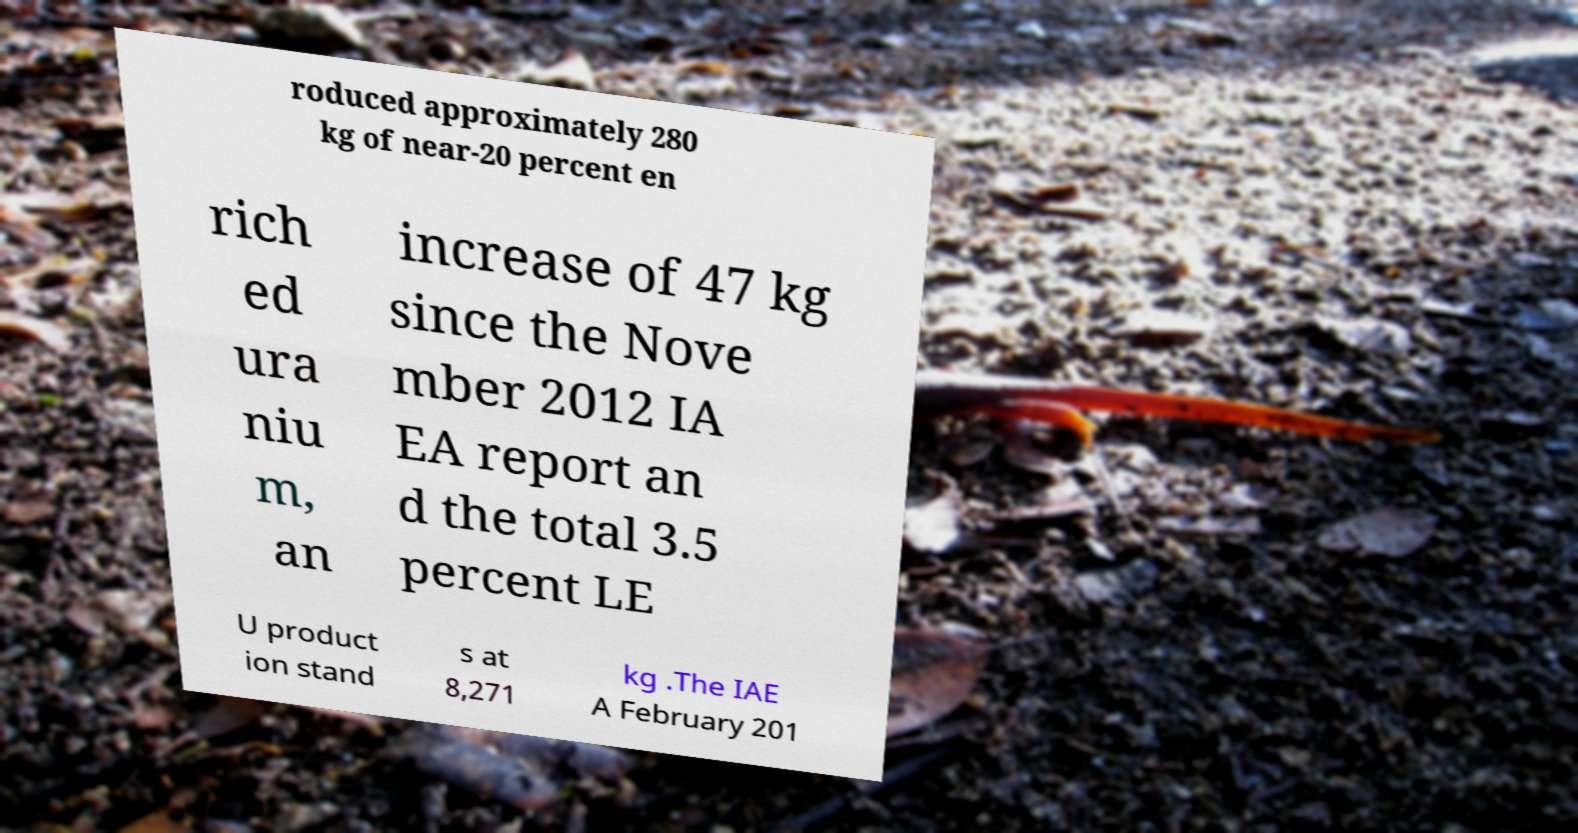There's text embedded in this image that I need extracted. Can you transcribe it verbatim? roduced approximately 280 kg of near-20 percent en rich ed ura niu m, an increase of 47 kg since the Nove mber 2012 IA EA report an d the total 3.5 percent LE U product ion stand s at 8,271 kg .The IAE A February 201 